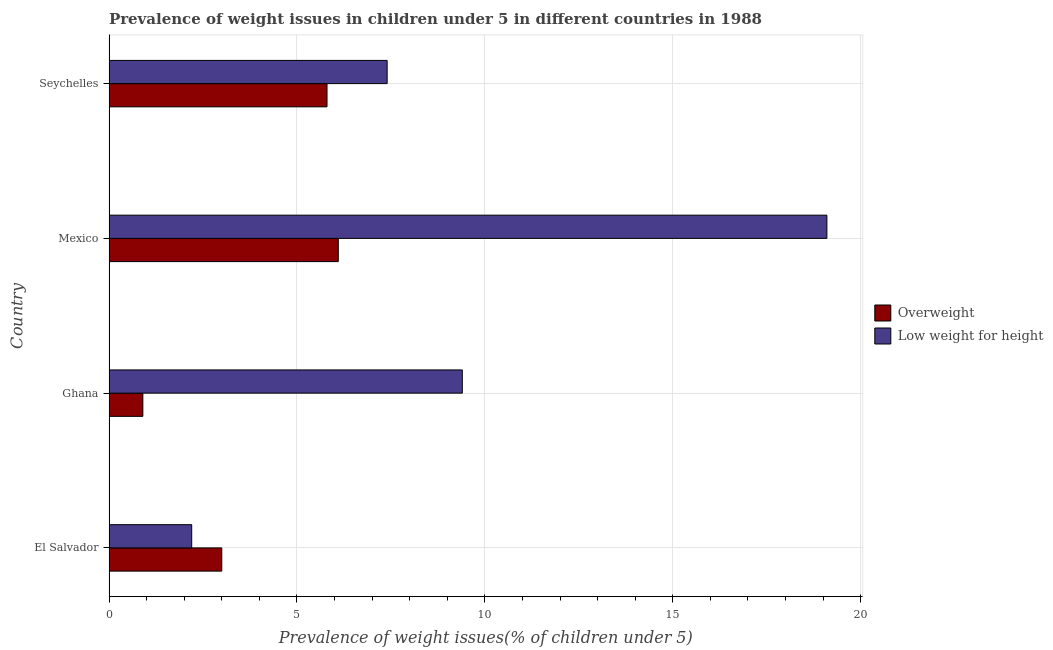Are the number of bars per tick equal to the number of legend labels?
Give a very brief answer. Yes. How many bars are there on the 4th tick from the top?
Offer a very short reply. 2. How many bars are there on the 2nd tick from the bottom?
Make the answer very short. 2. What is the label of the 3rd group of bars from the top?
Your answer should be compact. Ghana. In how many cases, is the number of bars for a given country not equal to the number of legend labels?
Provide a succinct answer. 0. What is the percentage of overweight children in El Salvador?
Offer a very short reply. 3. Across all countries, what is the maximum percentage of overweight children?
Your answer should be compact. 6.1. Across all countries, what is the minimum percentage of underweight children?
Make the answer very short. 2.2. In which country was the percentage of underweight children maximum?
Your response must be concise. Mexico. In which country was the percentage of underweight children minimum?
Ensure brevity in your answer.  El Salvador. What is the total percentage of overweight children in the graph?
Provide a succinct answer. 15.8. What is the difference between the percentage of underweight children in Seychelles and the percentage of overweight children in Ghana?
Offer a terse response. 6.5. What is the average percentage of overweight children per country?
Provide a succinct answer. 3.95. What is the difference between the percentage of overweight children and percentage of underweight children in Ghana?
Give a very brief answer. -8.5. What is the ratio of the percentage of underweight children in Ghana to that in Seychelles?
Make the answer very short. 1.27. What is the difference between the highest and the second highest percentage of overweight children?
Provide a succinct answer. 0.3. In how many countries, is the percentage of overweight children greater than the average percentage of overweight children taken over all countries?
Provide a short and direct response. 2. What does the 2nd bar from the top in El Salvador represents?
Give a very brief answer. Overweight. What does the 2nd bar from the bottom in Seychelles represents?
Make the answer very short. Low weight for height. How many countries are there in the graph?
Give a very brief answer. 4. Are the values on the major ticks of X-axis written in scientific E-notation?
Provide a succinct answer. No. Does the graph contain any zero values?
Offer a very short reply. No. Where does the legend appear in the graph?
Offer a terse response. Center right. How are the legend labels stacked?
Offer a very short reply. Vertical. What is the title of the graph?
Give a very brief answer. Prevalence of weight issues in children under 5 in different countries in 1988. Does "Resident" appear as one of the legend labels in the graph?
Make the answer very short. No. What is the label or title of the X-axis?
Offer a very short reply. Prevalence of weight issues(% of children under 5). What is the Prevalence of weight issues(% of children under 5) in Low weight for height in El Salvador?
Your answer should be very brief. 2.2. What is the Prevalence of weight issues(% of children under 5) of Overweight in Ghana?
Make the answer very short. 0.9. What is the Prevalence of weight issues(% of children under 5) in Low weight for height in Ghana?
Ensure brevity in your answer.  9.4. What is the Prevalence of weight issues(% of children under 5) of Overweight in Mexico?
Provide a succinct answer. 6.1. What is the Prevalence of weight issues(% of children under 5) of Low weight for height in Mexico?
Your response must be concise. 19.1. What is the Prevalence of weight issues(% of children under 5) of Overweight in Seychelles?
Offer a very short reply. 5.8. What is the Prevalence of weight issues(% of children under 5) of Low weight for height in Seychelles?
Give a very brief answer. 7.4. Across all countries, what is the maximum Prevalence of weight issues(% of children under 5) in Overweight?
Give a very brief answer. 6.1. Across all countries, what is the maximum Prevalence of weight issues(% of children under 5) in Low weight for height?
Provide a succinct answer. 19.1. Across all countries, what is the minimum Prevalence of weight issues(% of children under 5) of Overweight?
Give a very brief answer. 0.9. Across all countries, what is the minimum Prevalence of weight issues(% of children under 5) of Low weight for height?
Provide a short and direct response. 2.2. What is the total Prevalence of weight issues(% of children under 5) of Overweight in the graph?
Keep it short and to the point. 15.8. What is the total Prevalence of weight issues(% of children under 5) in Low weight for height in the graph?
Keep it short and to the point. 38.1. What is the difference between the Prevalence of weight issues(% of children under 5) of Low weight for height in El Salvador and that in Ghana?
Make the answer very short. -7.2. What is the difference between the Prevalence of weight issues(% of children under 5) in Low weight for height in El Salvador and that in Mexico?
Your response must be concise. -16.9. What is the difference between the Prevalence of weight issues(% of children under 5) of Low weight for height in El Salvador and that in Seychelles?
Give a very brief answer. -5.2. What is the difference between the Prevalence of weight issues(% of children under 5) of Overweight in Ghana and that in Mexico?
Offer a very short reply. -5.2. What is the difference between the Prevalence of weight issues(% of children under 5) of Overweight in Ghana and that in Seychelles?
Your answer should be compact. -4.9. What is the difference between the Prevalence of weight issues(% of children under 5) of Low weight for height in Mexico and that in Seychelles?
Keep it short and to the point. 11.7. What is the difference between the Prevalence of weight issues(% of children under 5) in Overweight in El Salvador and the Prevalence of weight issues(% of children under 5) in Low weight for height in Mexico?
Offer a very short reply. -16.1. What is the difference between the Prevalence of weight issues(% of children under 5) in Overweight in El Salvador and the Prevalence of weight issues(% of children under 5) in Low weight for height in Seychelles?
Make the answer very short. -4.4. What is the difference between the Prevalence of weight issues(% of children under 5) of Overweight in Ghana and the Prevalence of weight issues(% of children under 5) of Low weight for height in Mexico?
Make the answer very short. -18.2. What is the difference between the Prevalence of weight issues(% of children under 5) in Overweight in Ghana and the Prevalence of weight issues(% of children under 5) in Low weight for height in Seychelles?
Provide a short and direct response. -6.5. What is the average Prevalence of weight issues(% of children under 5) in Overweight per country?
Provide a succinct answer. 3.95. What is the average Prevalence of weight issues(% of children under 5) in Low weight for height per country?
Offer a very short reply. 9.53. What is the difference between the Prevalence of weight issues(% of children under 5) in Overweight and Prevalence of weight issues(% of children under 5) in Low weight for height in Mexico?
Your answer should be compact. -13. What is the difference between the Prevalence of weight issues(% of children under 5) of Overweight and Prevalence of weight issues(% of children under 5) of Low weight for height in Seychelles?
Your answer should be compact. -1.6. What is the ratio of the Prevalence of weight issues(% of children under 5) in Overweight in El Salvador to that in Ghana?
Your answer should be very brief. 3.33. What is the ratio of the Prevalence of weight issues(% of children under 5) of Low weight for height in El Salvador to that in Ghana?
Your response must be concise. 0.23. What is the ratio of the Prevalence of weight issues(% of children under 5) of Overweight in El Salvador to that in Mexico?
Your response must be concise. 0.49. What is the ratio of the Prevalence of weight issues(% of children under 5) in Low weight for height in El Salvador to that in Mexico?
Your response must be concise. 0.12. What is the ratio of the Prevalence of weight issues(% of children under 5) in Overweight in El Salvador to that in Seychelles?
Provide a succinct answer. 0.52. What is the ratio of the Prevalence of weight issues(% of children under 5) in Low weight for height in El Salvador to that in Seychelles?
Make the answer very short. 0.3. What is the ratio of the Prevalence of weight issues(% of children under 5) of Overweight in Ghana to that in Mexico?
Make the answer very short. 0.15. What is the ratio of the Prevalence of weight issues(% of children under 5) of Low weight for height in Ghana to that in Mexico?
Offer a very short reply. 0.49. What is the ratio of the Prevalence of weight issues(% of children under 5) in Overweight in Ghana to that in Seychelles?
Keep it short and to the point. 0.16. What is the ratio of the Prevalence of weight issues(% of children under 5) of Low weight for height in Ghana to that in Seychelles?
Your answer should be compact. 1.27. What is the ratio of the Prevalence of weight issues(% of children under 5) in Overweight in Mexico to that in Seychelles?
Your answer should be very brief. 1.05. What is the ratio of the Prevalence of weight issues(% of children under 5) of Low weight for height in Mexico to that in Seychelles?
Give a very brief answer. 2.58. What is the difference between the highest and the second highest Prevalence of weight issues(% of children under 5) of Overweight?
Offer a very short reply. 0.3. 